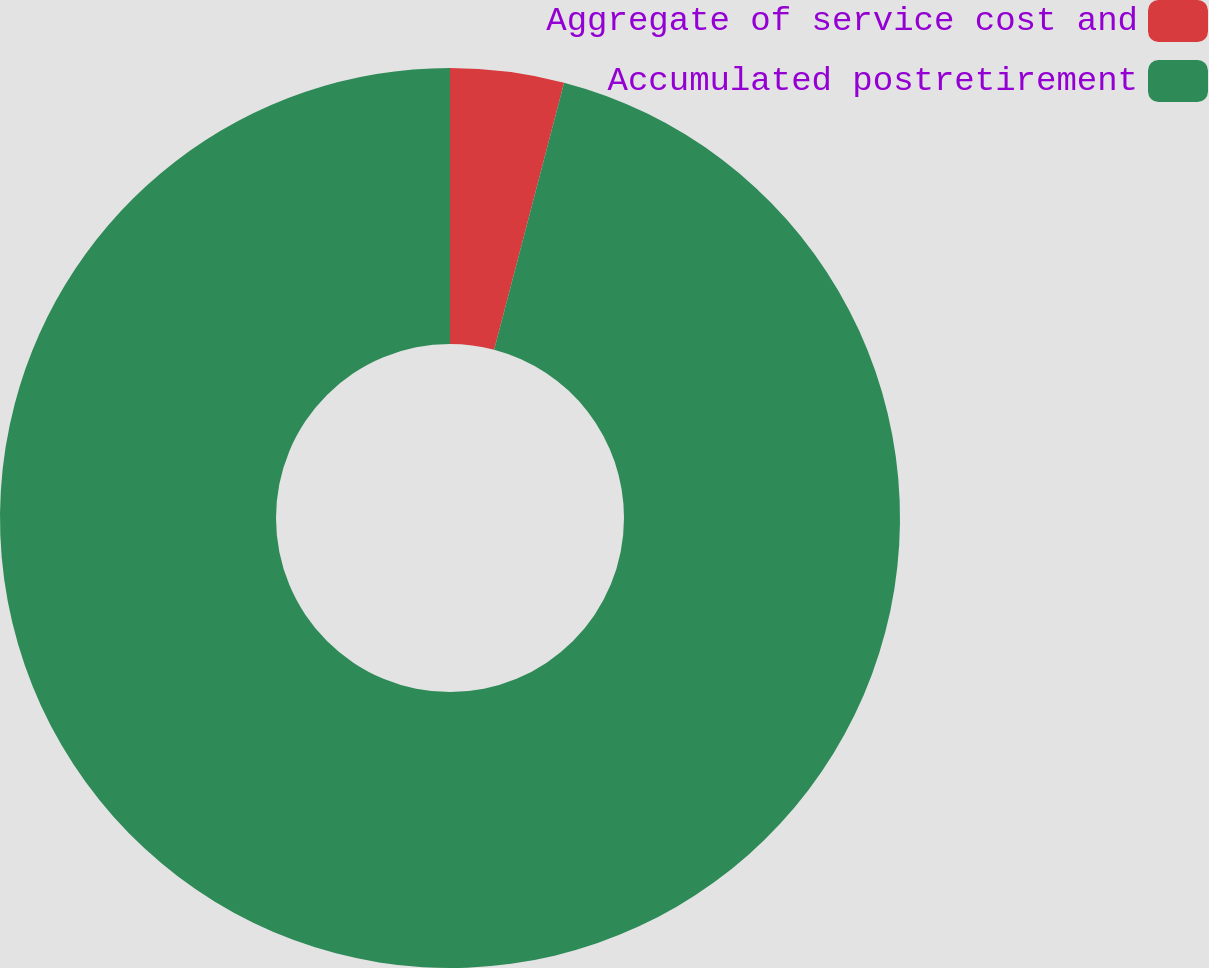<chart> <loc_0><loc_0><loc_500><loc_500><pie_chart><fcel>Aggregate of service cost and<fcel>Accumulated postretirement<nl><fcel>4.08%<fcel>95.92%<nl></chart> 